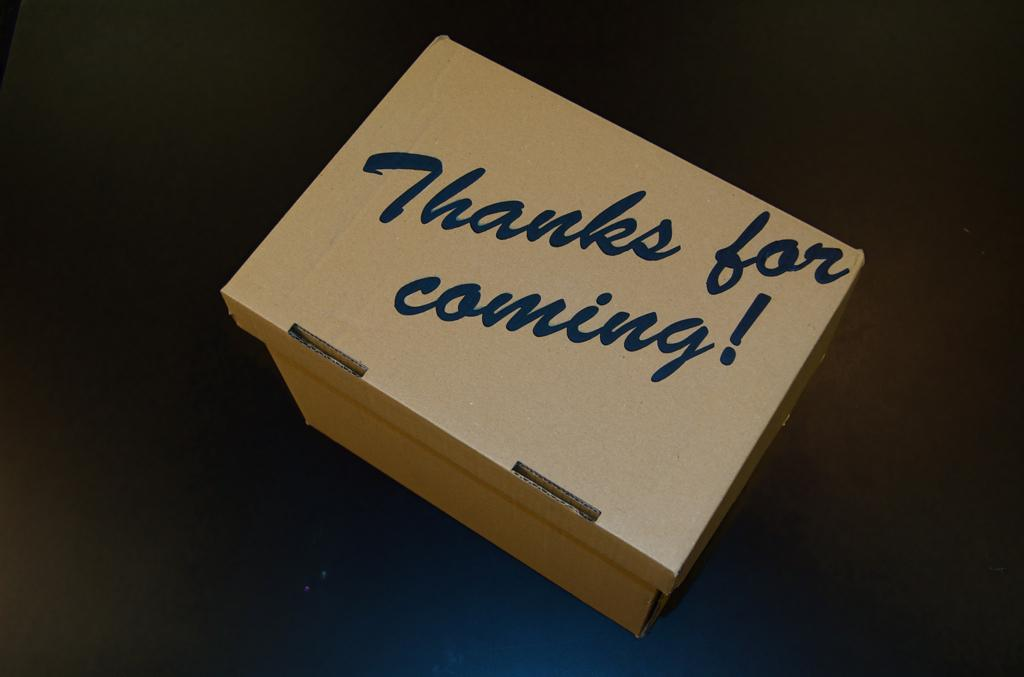<image>
Provide a brief description of the given image. A box full of thanks for taking the time to attend the event. 